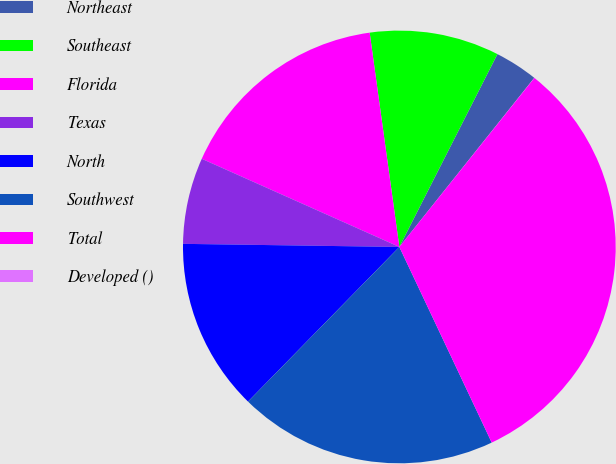Convert chart to OTSL. <chart><loc_0><loc_0><loc_500><loc_500><pie_chart><fcel>Northeast<fcel>Southeast<fcel>Florida<fcel>Texas<fcel>North<fcel>Southwest<fcel>Total<fcel>Developed ()<nl><fcel>3.23%<fcel>9.68%<fcel>16.13%<fcel>6.45%<fcel>12.9%<fcel>19.35%<fcel>32.25%<fcel>0.01%<nl></chart> 